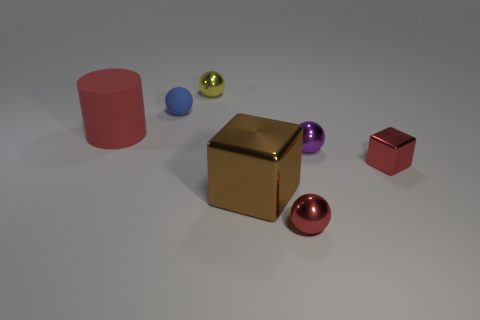Add 2 big red balls. How many objects exist? 9 Subtract all cylinders. How many objects are left? 6 Add 3 blue rubber things. How many blue rubber things are left? 4 Add 7 brown objects. How many brown objects exist? 8 Subtract 0 cyan balls. How many objects are left? 7 Subtract all brown matte things. Subtract all blue rubber balls. How many objects are left? 6 